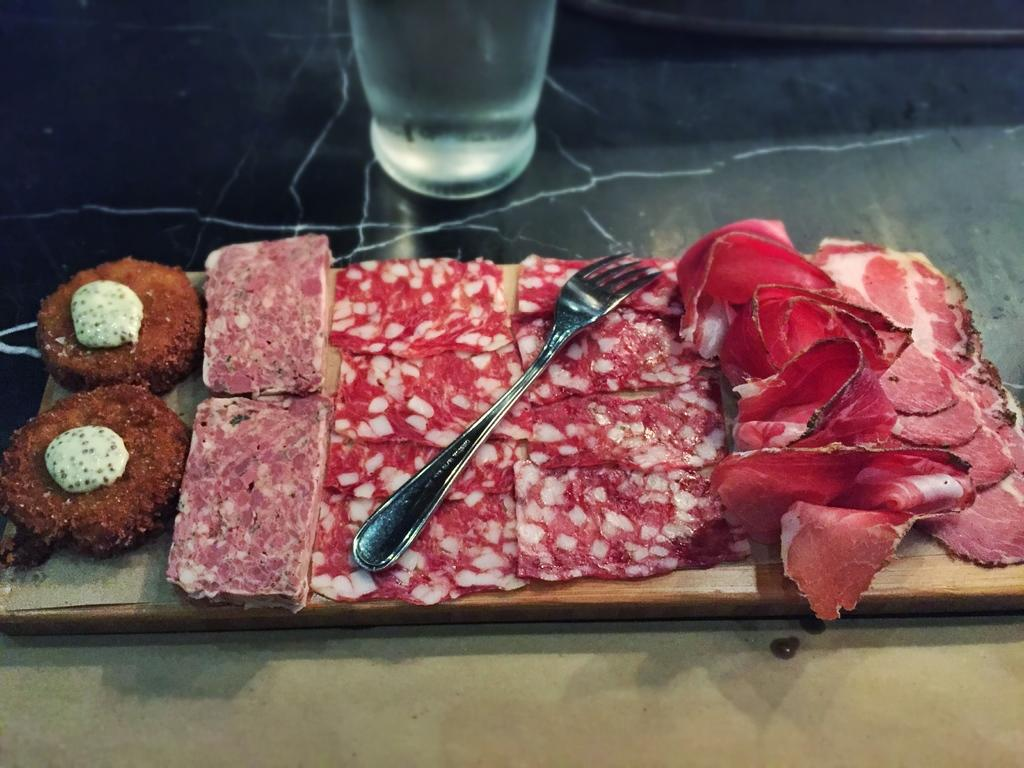What is on the serving plate in the image? The serving plate has slices of meat on it. What utensil is placed on the serving plate? There is a fork on the serving plate. What type of container is present in the image? There is a glass tumbler in the image. Is the existence of a faucet confirmed in the image? No, there is no mention of a faucet in the provided facts, and therefore it cannot be confirmed that a faucet is present in the image. 